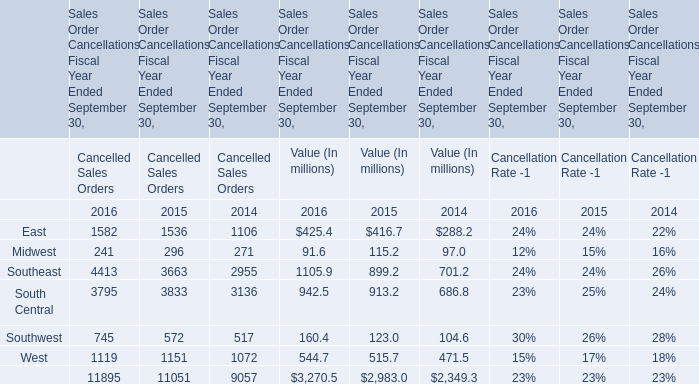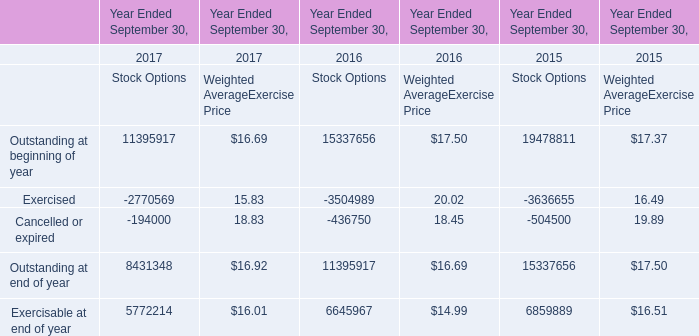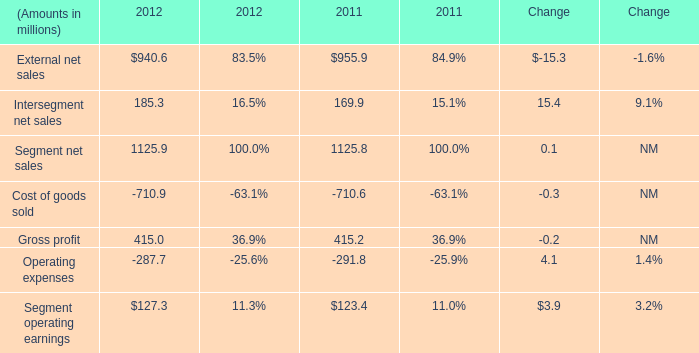What's the current growth rate of the total Value of Sales Order Cancellations Fiscal Year Ended September 30? 
Computations: ((3270.5 - 2983.0) / 2983.0)
Answer: 0.09638. 